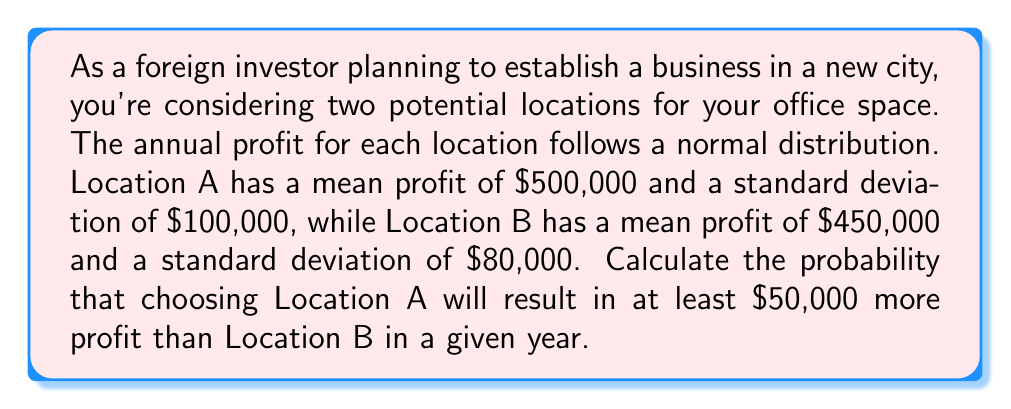Could you help me with this problem? To solve this problem, we need to follow these steps:

1) First, we need to find the distribution of the difference in profits between Location A and Location B.

   Let X be the profit from Location A and Y be the profit from Location B.
   We're interested in Z = X - Y

   Given:
   X ~ N($500,000, 100,000^2$)
   Y ~ N($450,000, 80,000^2$)

   Properties of normal distributions tell us that:
   Z ~ N($\mu_X - \mu_Y, \sqrt{\sigma_X^2 + \sigma_Y^2}$)

   So, Z ~ N($500,000 - 450,000, \sqrt{100,000^2 + 80,000^2}$)
   Z ~ N($50,000, \sqrt{16,400,000,000}$)
   Z ~ N($50,000, 128,062.48$)

2) Now, we need to find P(Z ≥ 50,000)

3) We can standardize this to a standard normal distribution:

   $$P(Z \geq 50,000) = P\left(\frac{Z - \mu}{\sigma} \geq \frac{50,000 - 50,000}{128,062.48}\right)$$

   $$= P(Z \geq 0)$$

4) From the standard normal distribution table, we know that P(Z ≥ 0) = 0.5

Therefore, the probability that choosing Location A will result in at least $50,000 more profit than Location B in a given year is 0.5 or 50%.
Answer: 0.5 